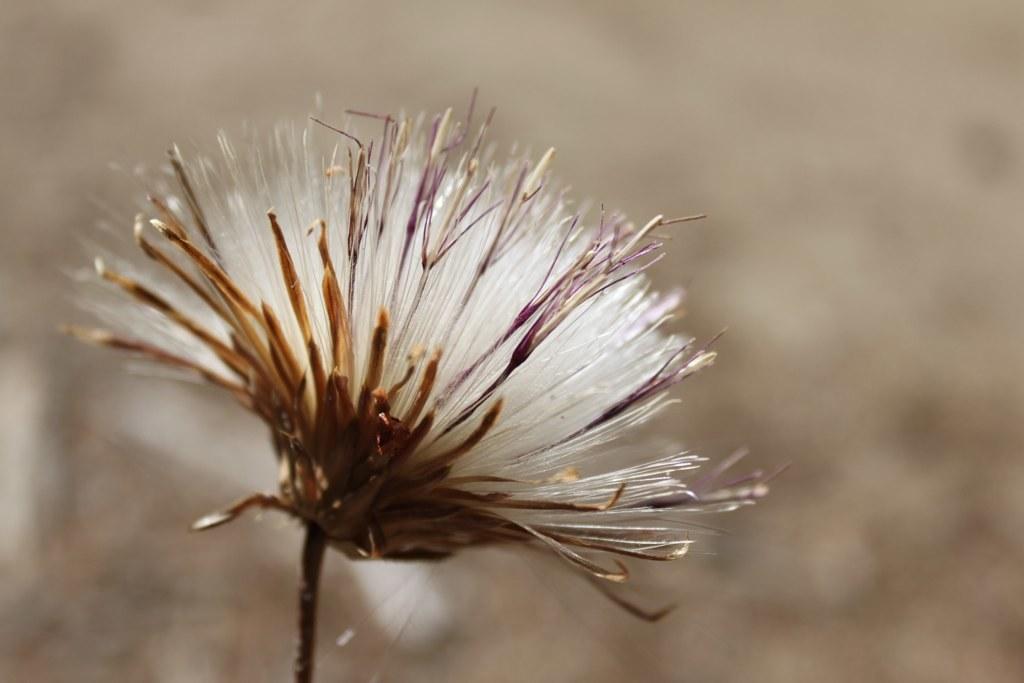Can you describe this image briefly? In this image I can see a flower to a stem. The background is blurred. 